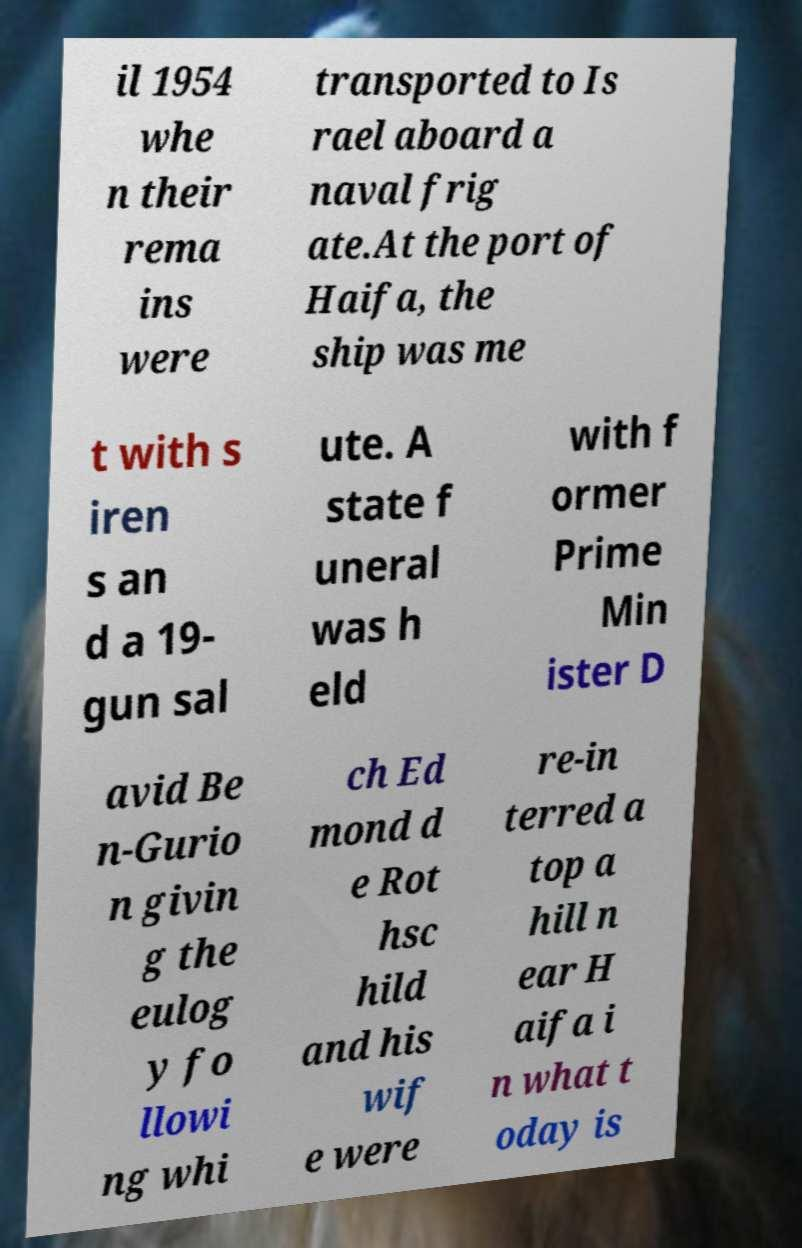I need the written content from this picture converted into text. Can you do that? il 1954 whe n their rema ins were transported to Is rael aboard a naval frig ate.At the port of Haifa, the ship was me t with s iren s an d a 19- gun sal ute. A state f uneral was h eld with f ormer Prime Min ister D avid Be n-Gurio n givin g the eulog y fo llowi ng whi ch Ed mond d e Rot hsc hild and his wif e were re-in terred a top a hill n ear H aifa i n what t oday is 